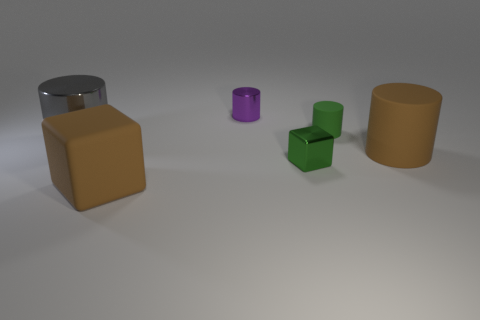Add 3 big gray shiny objects. How many objects exist? 9 Subtract all blocks. How many objects are left? 4 Add 3 big blue metallic objects. How many big blue metallic objects exist? 3 Subtract 0 gray cubes. How many objects are left? 6 Subtract all yellow metal things. Subtract all green matte objects. How many objects are left? 5 Add 5 brown rubber blocks. How many brown rubber blocks are left? 6 